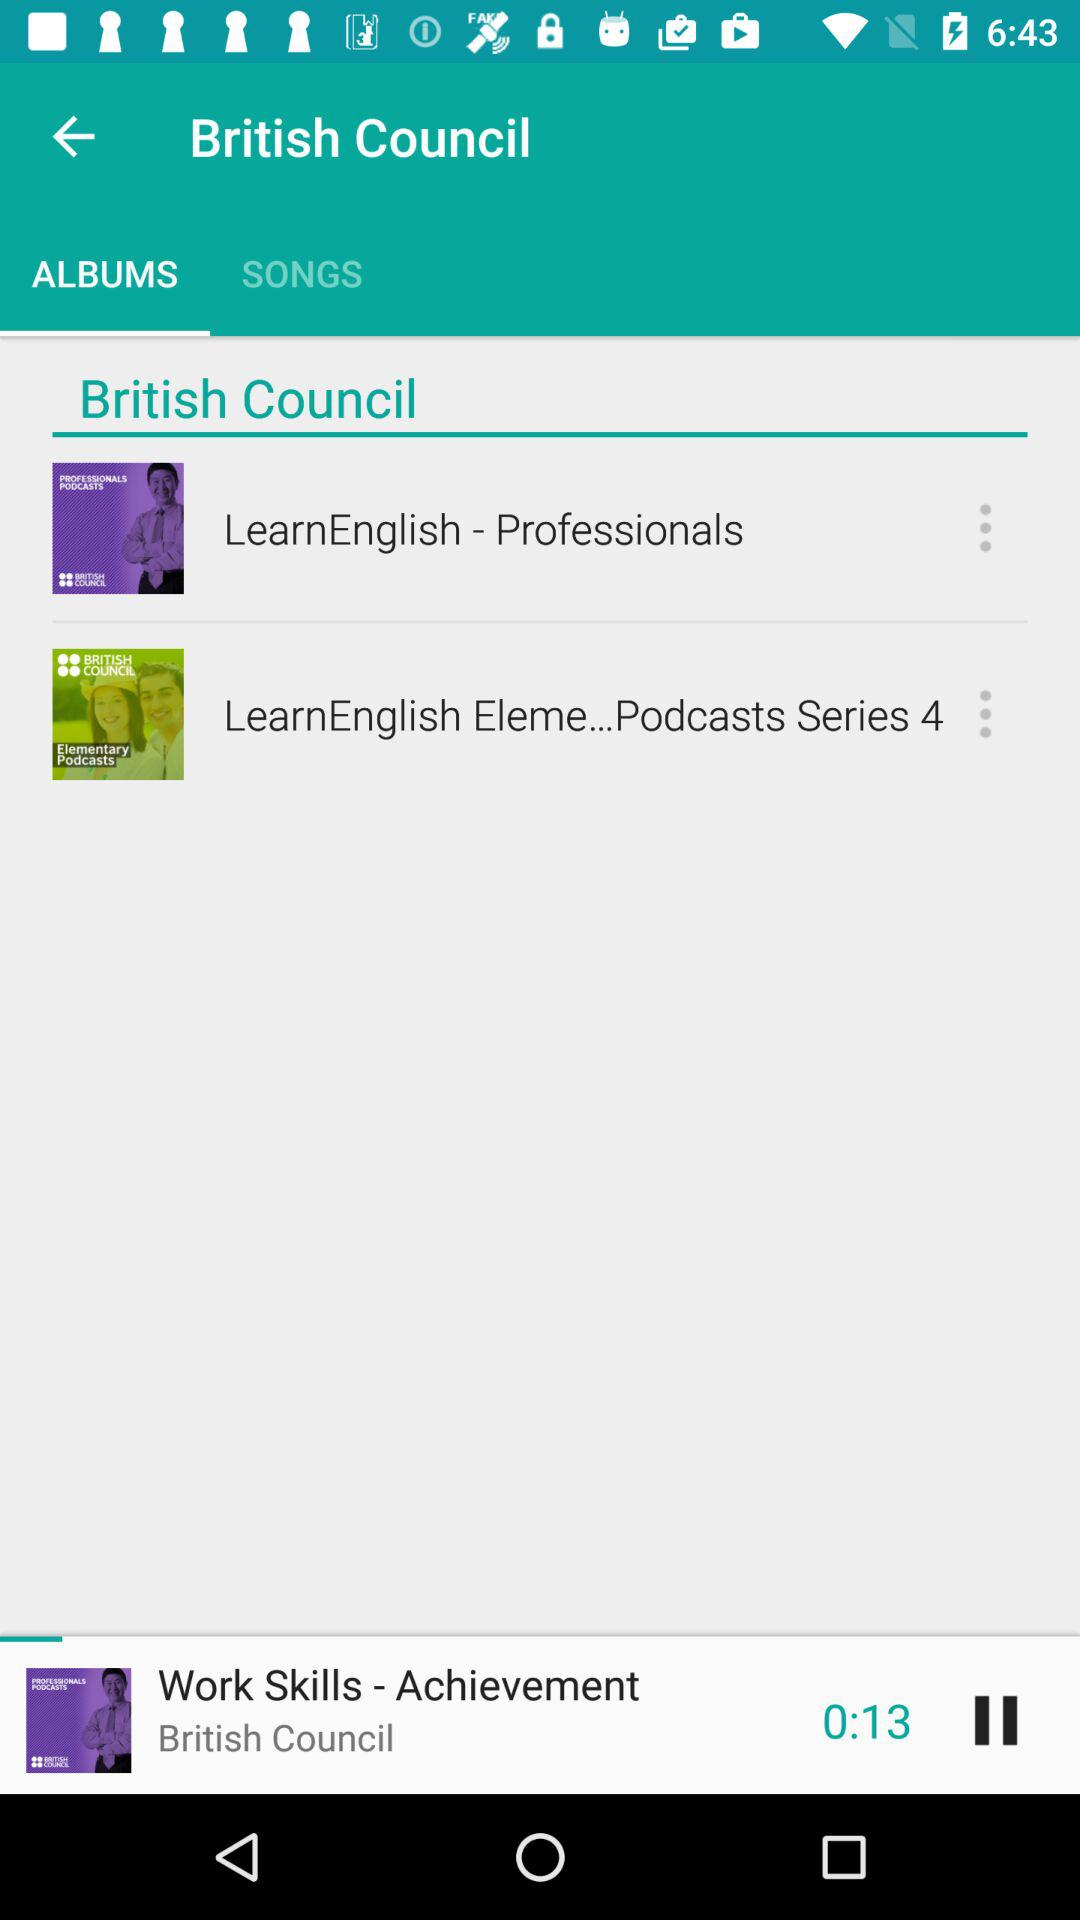How long is the current video?
Answer the question using a single word or phrase. 0:13 